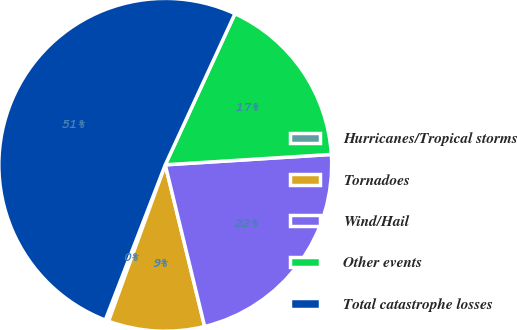<chart> <loc_0><loc_0><loc_500><loc_500><pie_chart><fcel>Hurricanes/Tropical storms<fcel>Tornadoes<fcel>Wind/Hail<fcel>Other events<fcel>Total catastrophe losses<nl><fcel>0.33%<fcel>9.34%<fcel>22.19%<fcel>17.13%<fcel>51.01%<nl></chart> 